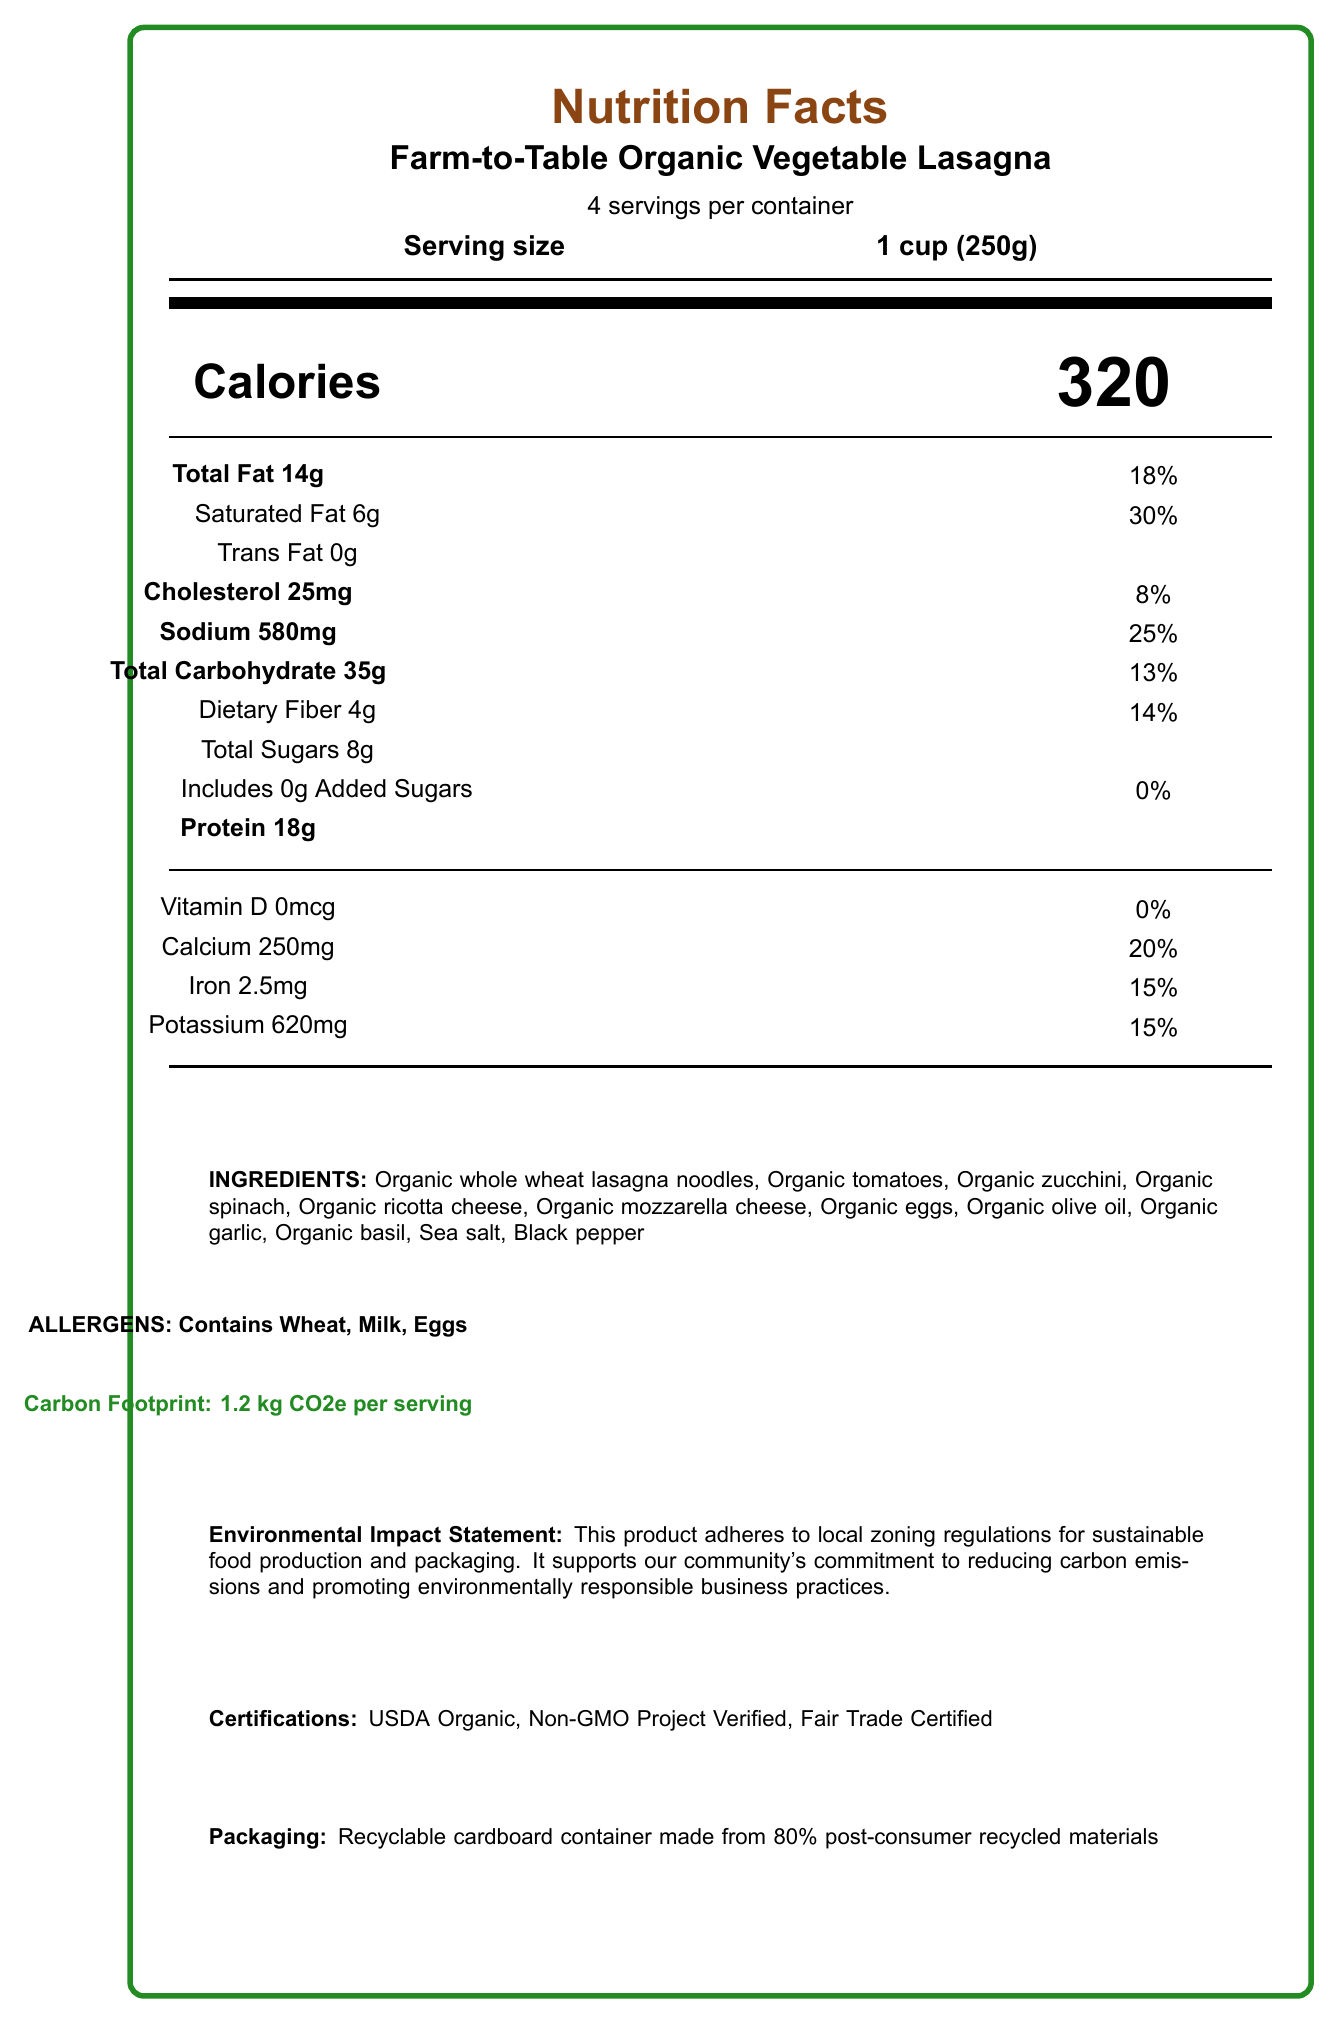what is the serving size? The serving size is explicitly stated at the top of the document under the product name.
Answer: 1 cup (250g) how many calories are in one serving? The calorie count for one serving is prominently displayed in large font in the middle of the document.
Answer: 320 what percentage of the daily value of saturated fat does one serving contain? This information is located under the saturated fat section of the document.
Answer: 30% list all allergens present in this product. The allergens are listed explicitly under the section labeled "ALLERGENS".
Answer: Wheat, Milk, Eggs what is the total carbon footprint per serving? This information is highlighted in the document under the "Carbon Footprint" section.
Answer: 1.2 kg CO2e per serving which component contributes the most to the carbon footprint of the product? A. ingredients_production B. processing C. packaging D. transportation The breakdown shows that ingredients production contributes 0.7 kg CO2e, which is the highest among the listed categories.
Answer: A what is one of the sustainability certifications listed for this product? A. USDA Organic B. Rainforest Alliance C. LEED Certified D. Energy Star The product lists USDA Organic as one of its sustainability certifications, displayed near the bottom of the document.
Answer: A does the product contain any trans fat? The trans fat content is listed as 0g in the document.
Answer: No describe the packaging of this product. This information is provided near the bottom of the document under the "Packaging" section.
Answer: The packaging is a recyclable cardboard container made from 80% post-consumer recycled materials. which farm provides the vegetables for this product? The vegetables are sourced from Green Valley Organic Farm, mentioned under the sourcing_information section.
Answer: Green Valley Organic Farm how does the product comply with local zoning regulations? This is explicitly stated in the environmental_impact_statement section of the document.
Answer: The product adheres to local zoning regulations for sustainable food production and packaging, supporting the community's commitment to reducing carbon emissions and promoting environmentally responsible business practices. does this product contain added sugars? The document states there are 0g of added sugars in the product.
Answer: No is the container compostable? The document mentions the packaging is recyclable and made from 80% post-consumer recycled materials but does not specify whether it is compostable.
Answer: Cannot be determined 